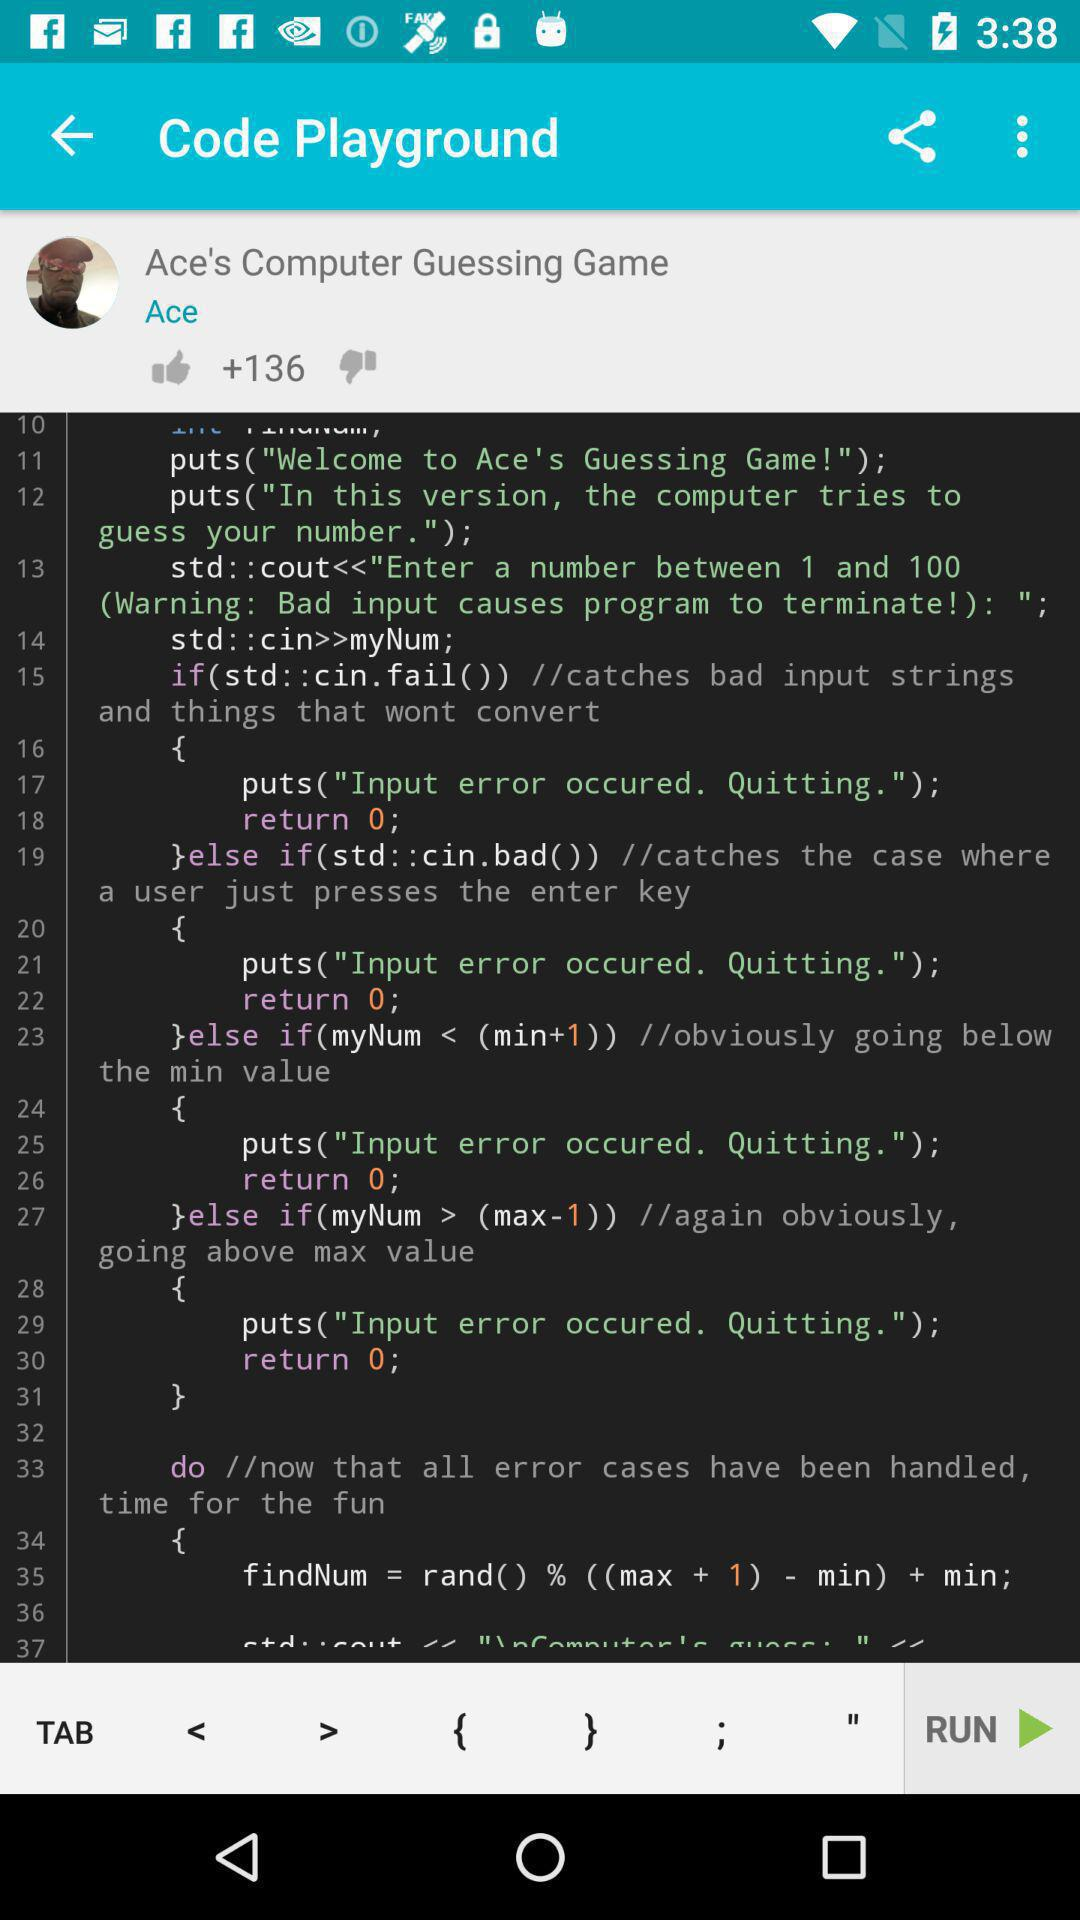How many likes are there? There are 136 likes. 